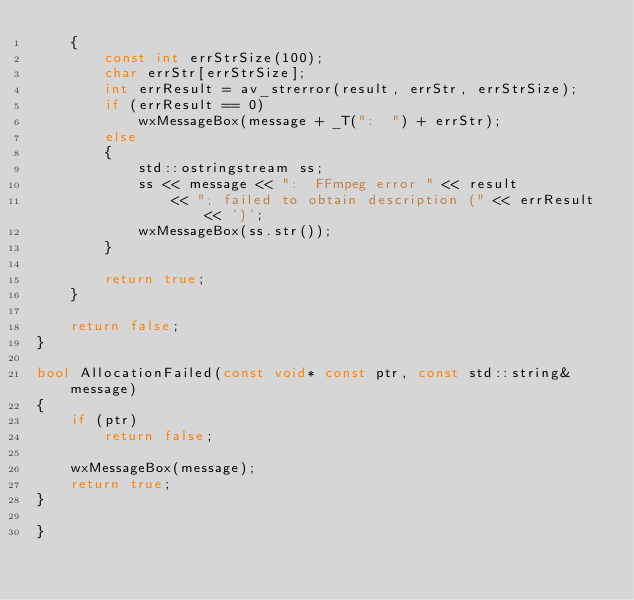Convert code to text. <code><loc_0><loc_0><loc_500><loc_500><_C++_>	{
		const int errStrSize(100);
		char errStr[errStrSize];
		int errResult = av_strerror(result, errStr, errStrSize);
		if (errResult == 0)
			wxMessageBox(message + _T(":  ") + errStr);
		else
		{
			std::ostringstream ss;
			ss << message << ":  FFmpeg error " << result
				<< "; failed to obtain description (" << errResult << ')';
			wxMessageBox(ss.str());
		}

		return true;
	}

	return false;
}

bool AllocationFailed(const void* const ptr, const std::string& message)
{
	if (ptr)
		return false;

	wxMessageBox(message);
	return true;
}

}

</code> 